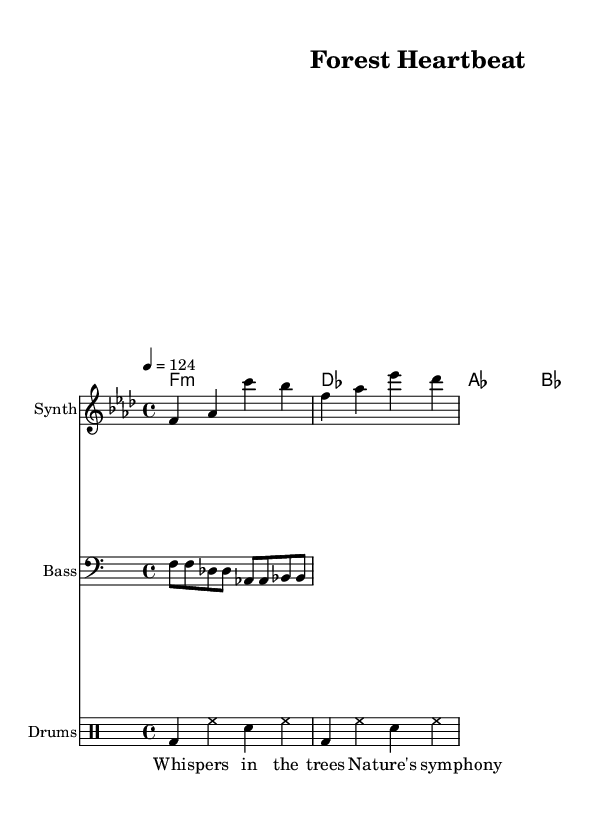What is the key signature of this music? The key signature indicated in the sheet music is F minor, which has four flats (B♭, E♭, A♭, D♭). This can be identified from the key signature notation at the beginning of the staff.
Answer: F minor What is the time signature of the piece? The time signature shown at the beginning of the music is 4/4, which means there are four beats in each measure and the quarter note gets one beat. This can be confirmed by looking at the notation that appears at the start of the music.
Answer: 4/4 What is the tempo marking for this piece? The tempo marking is indicated as 124 beats per minute, which is noted as "4 = 124" in the sheet music. This signifies the speed at which the piece should be played.
Answer: 124 How many measures does the melody contain? The melody consists of two measures, each indicated by the bar lines present in the staff. Each measure contains a grouping of the notes presented in the melody line.
Answer: 2 What is the first chord in the harmony section? The first chord in the harmony section is F minor, which is noted as "f1:m" in the chord notation. This denotes that F minor is played for one whole measure.
Answer: F minor What is the instrument played for the melody? The instrument indicated for the melody in the score is "Synth," as shown in the staff label. This denotes the character of sound for the melody line.
Answer: Synth What theme do the lyrics focus on? The lyrics focus on nature and wildlife, as highlighted by the phrases "Whispers in the trees" and "Nature's symphony," which reflect themes of environmental conservation.
Answer: Nature 